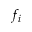<formula> <loc_0><loc_0><loc_500><loc_500>f _ { i }</formula> 